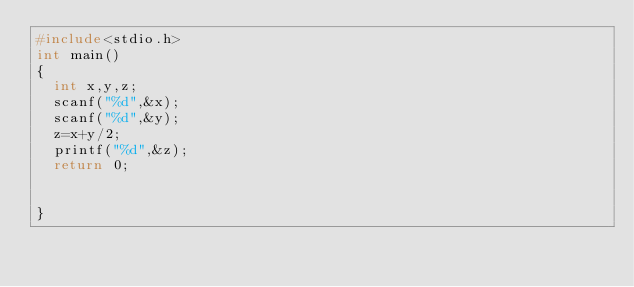Convert code to text. <code><loc_0><loc_0><loc_500><loc_500><_C_>#include<stdio.h>
int main()
{
	int x,y,z;
	scanf("%d",&x);
	scanf("%d",&y);
	z=x+y/2;
	printf("%d",&z);
	return 0;
	
	
}</code> 